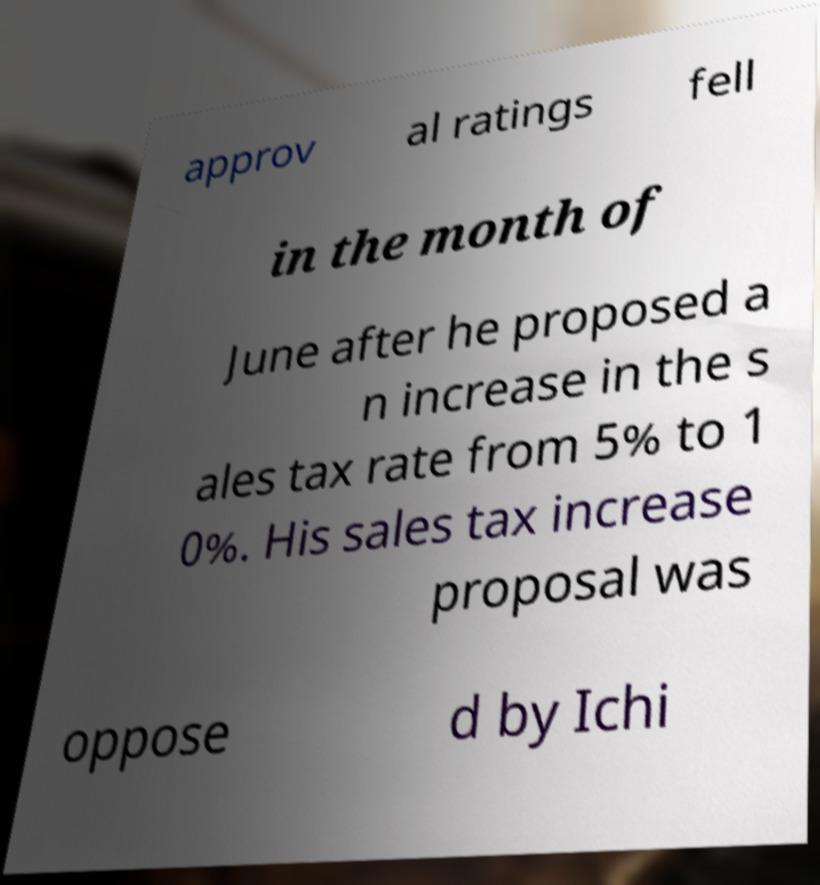Please read and relay the text visible in this image. What does it say? approv al ratings fell in the month of June after he proposed a n increase in the s ales tax rate from 5% to 1 0%. His sales tax increase proposal was oppose d by Ichi 